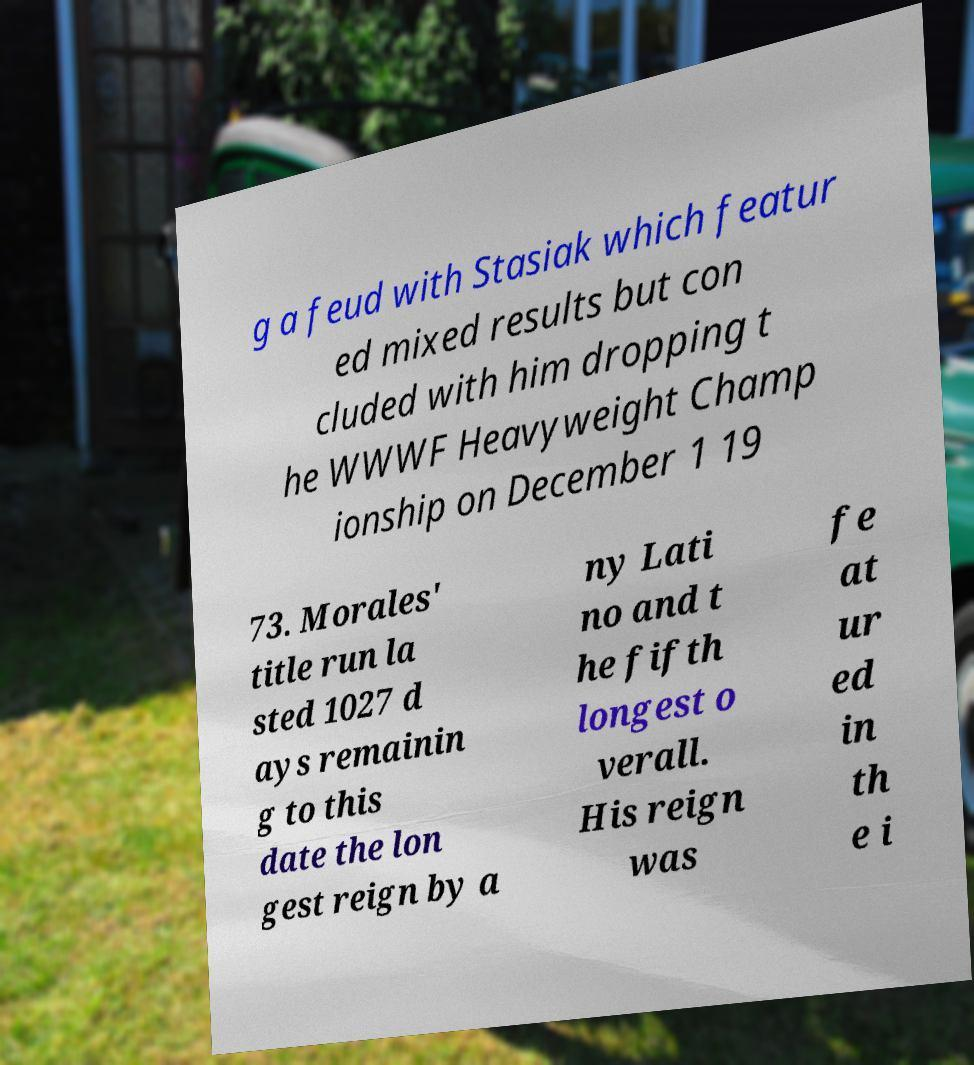Please identify and transcribe the text found in this image. g a feud with Stasiak which featur ed mixed results but con cluded with him dropping t he WWWF Heavyweight Champ ionship on December 1 19 73. Morales' title run la sted 1027 d ays remainin g to this date the lon gest reign by a ny Lati no and t he fifth longest o verall. His reign was fe at ur ed in th e i 